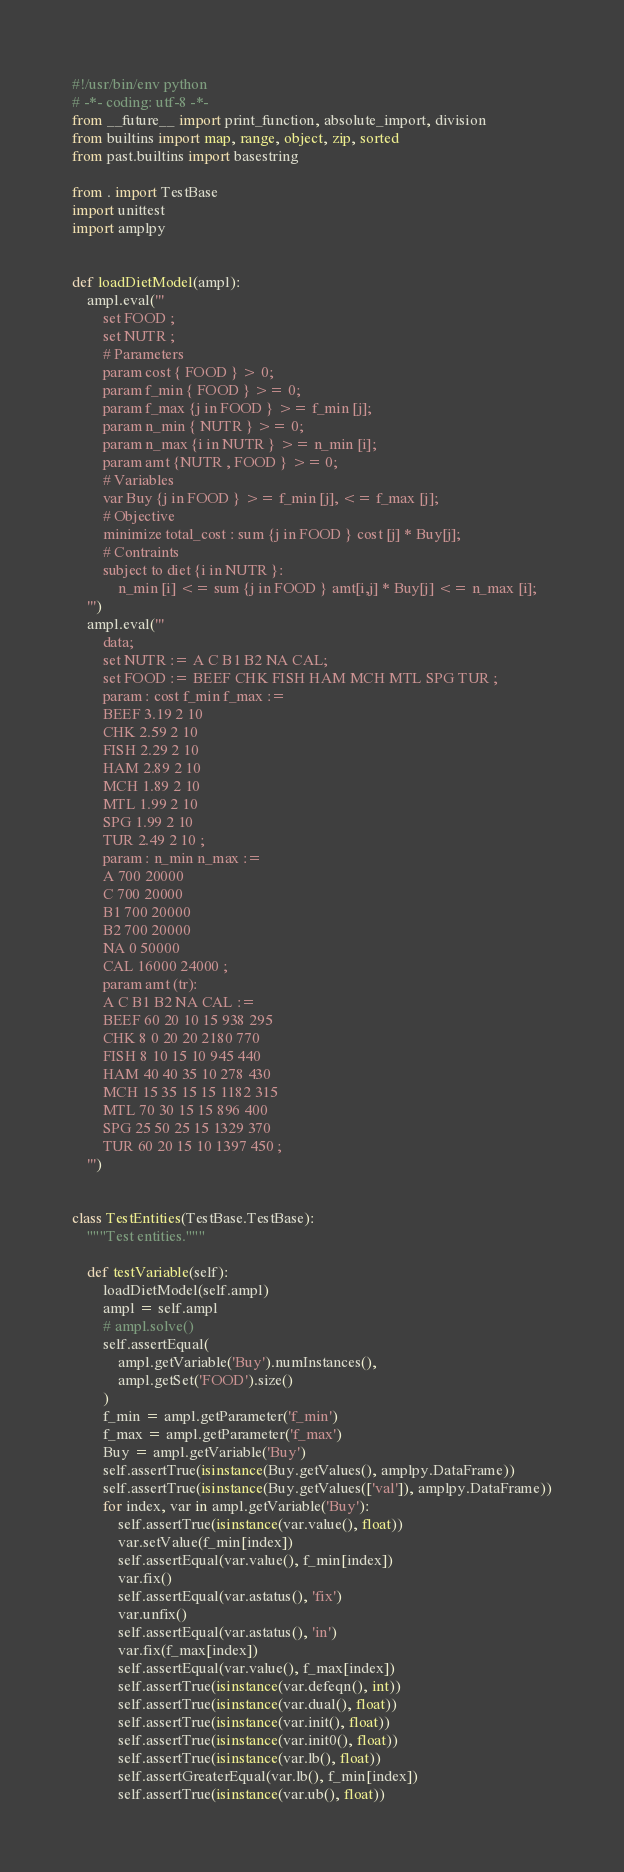<code> <loc_0><loc_0><loc_500><loc_500><_Python_>#!/usr/bin/env python
# -*- coding: utf-8 -*-
from __future__ import print_function, absolute_import, division
from builtins import map, range, object, zip, sorted
from past.builtins import basestring

from . import TestBase
import unittest
import amplpy


def loadDietModel(ampl):
    ampl.eval('''
        set FOOD ;
        set NUTR ;
        # Parameters
        param cost { FOOD } > 0;
        param f_min { FOOD } >= 0;
        param f_max {j in FOOD } >= f_min [j];
        param n_min { NUTR } >= 0;
        param n_max {i in NUTR } >= n_min [i];
        param amt {NUTR , FOOD } >= 0;
        # Variables
        var Buy {j in FOOD } >= f_min [j], <= f_max [j];
        # Objective
        minimize total_cost : sum {j in FOOD } cost [j] * Buy[j];
        # Contraints
        subject to diet {i in NUTR }:
            n_min [i] <= sum {j in FOOD } amt[i,j] * Buy[j] <= n_max [i];
    ''')
    ampl.eval('''
        data;
        set NUTR := A C B1 B2 NA CAL;
        set FOOD := BEEF CHK FISH HAM MCH MTL SPG TUR ;
        param : cost f_min f_max :=
        BEEF 3.19 2 10
        CHK 2.59 2 10
        FISH 2.29 2 10
        HAM 2.89 2 10
        MCH 1.89 2 10
        MTL 1.99 2 10
        SPG 1.99 2 10
        TUR 2.49 2 10 ;
        param : n_min n_max :=
        A 700 20000
        C 700 20000
        B1 700 20000
        B2 700 20000
        NA 0 50000
        CAL 16000 24000 ;
        param amt (tr):
        A C B1 B2 NA CAL :=
        BEEF 60 20 10 15 938 295
        CHK 8 0 20 20 2180 770
        FISH 8 10 15 10 945 440
        HAM 40 40 35 10 278 430
        MCH 15 35 15 15 1182 315
        MTL 70 30 15 15 896 400
        SPG 25 50 25 15 1329 370
        TUR 60 20 15 10 1397 450 ;
    ''')


class TestEntities(TestBase.TestBase):
    """Test entities."""

    def testVariable(self):
        loadDietModel(self.ampl)
        ampl = self.ampl
        # ampl.solve()
        self.assertEqual(
            ampl.getVariable('Buy').numInstances(),
            ampl.getSet('FOOD').size()
        )
        f_min = ampl.getParameter('f_min')
        f_max = ampl.getParameter('f_max')
        Buy = ampl.getVariable('Buy')
        self.assertTrue(isinstance(Buy.getValues(), amplpy.DataFrame))
        self.assertTrue(isinstance(Buy.getValues(['val']), amplpy.DataFrame))
        for index, var in ampl.getVariable('Buy'):
            self.assertTrue(isinstance(var.value(), float))
            var.setValue(f_min[index])
            self.assertEqual(var.value(), f_min[index])
            var.fix()
            self.assertEqual(var.astatus(), 'fix')
            var.unfix()
            self.assertEqual(var.astatus(), 'in')
            var.fix(f_max[index])
            self.assertEqual(var.value(), f_max[index])
            self.assertTrue(isinstance(var.defeqn(), int))
            self.assertTrue(isinstance(var.dual(), float))
            self.assertTrue(isinstance(var.init(), float))
            self.assertTrue(isinstance(var.init0(), float))
            self.assertTrue(isinstance(var.lb(), float))
            self.assertGreaterEqual(var.lb(), f_min[index])
            self.assertTrue(isinstance(var.ub(), float))</code> 